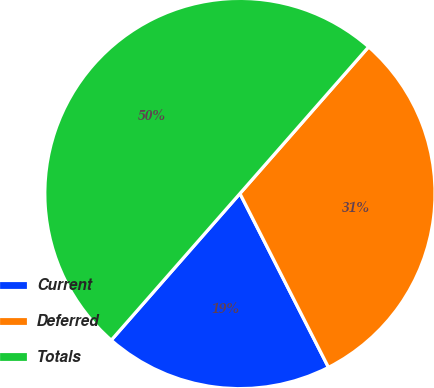<chart> <loc_0><loc_0><loc_500><loc_500><pie_chart><fcel>Current<fcel>Deferred<fcel>Totals<nl><fcel>18.96%<fcel>31.04%<fcel>50.0%<nl></chart> 